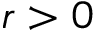Convert formula to latex. <formula><loc_0><loc_0><loc_500><loc_500>r > 0</formula> 